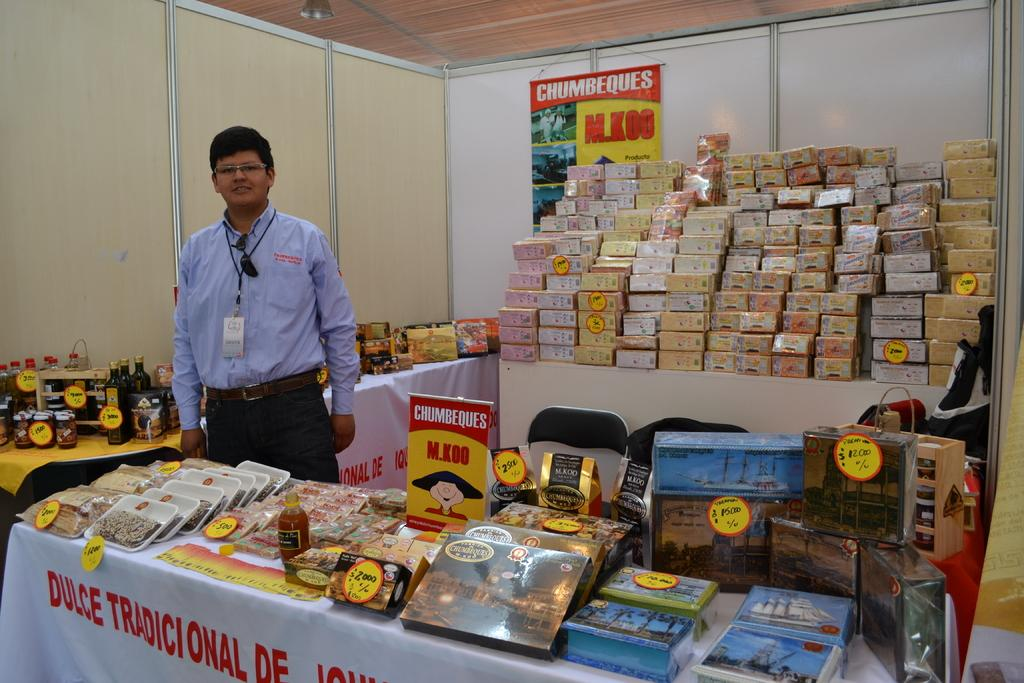Provide a one-sentence caption for the provided image. A vendor displaying products on tables near a chumbeques sign. 